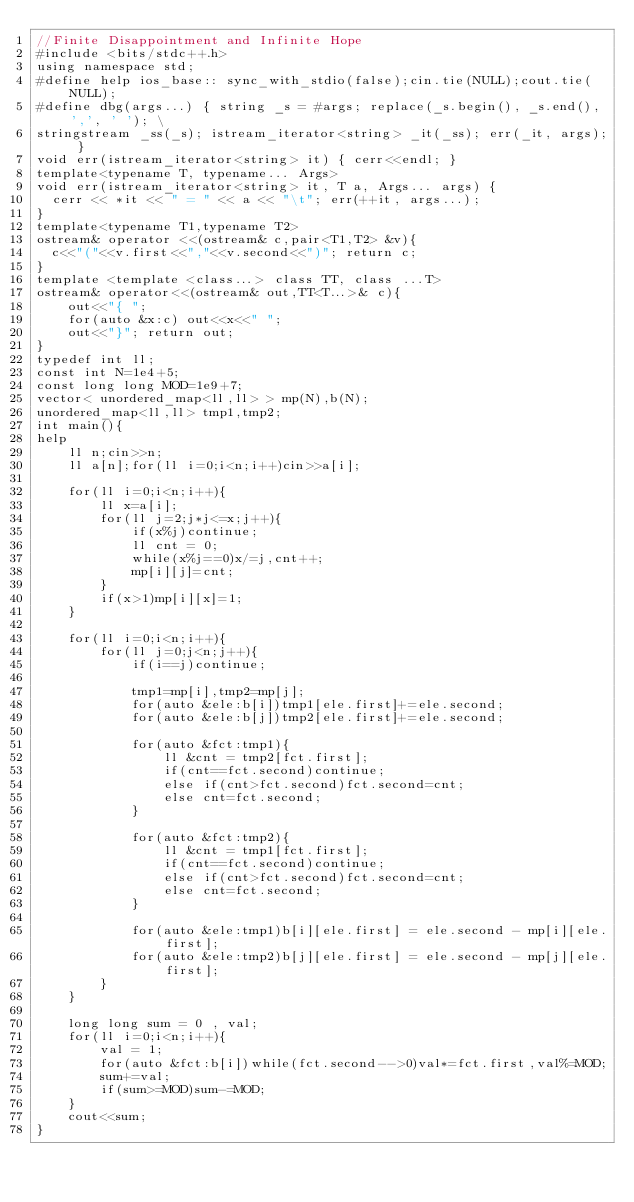Convert code to text. <code><loc_0><loc_0><loc_500><loc_500><_C++_>//Finite Disappointment and Infinite Hope
#include <bits/stdc++.h>
using namespace std;
#define help ios_base:: sync_with_stdio(false);cin.tie(NULL);cout.tie(NULL);
#define dbg(args...) { string _s = #args; replace(_s.begin(), _s.end(), ',', ' '); \
stringstream _ss(_s); istream_iterator<string> _it(_ss); err(_it, args); }
void err(istream_iterator<string> it) { cerr<<endl; }
template<typename T, typename... Args>
void err(istream_iterator<string> it, T a, Args... args) {
	cerr << *it << " = " << a << "\t"; err(++it, args...);
}
template<typename T1,typename T2>
ostream& operator <<(ostream& c,pair<T1,T2> &v){
	c<<"("<<v.first<<","<<v.second<<")"; return c;
}
template <template <class...> class TT, class ...T>
ostream& operator<<(ostream& out,TT<T...>& c){
    out<<"{ ";
    for(auto &x:c) out<<x<<" ";
    out<<"}"; return out;
}
typedef int ll;
const int N=1e4+5;
const long long MOD=1e9+7;
vector< unordered_map<ll,ll> > mp(N),b(N);
unordered_map<ll,ll> tmp1,tmp2;
int main(){
help
    ll n;cin>>n;
    ll a[n];for(ll i=0;i<n;i++)cin>>a[i];

    for(ll i=0;i<n;i++){
        ll x=a[i];
        for(ll j=2;j*j<=x;j++){
            if(x%j)continue;
            ll cnt = 0;
            while(x%j==0)x/=j,cnt++;
            mp[i][j]=cnt;
        }
        if(x>1)mp[i][x]=1;
    }

    for(ll i=0;i<n;i++){
        for(ll j=0;j<n;j++){
            if(i==j)continue;

            tmp1=mp[i],tmp2=mp[j];
            for(auto &ele:b[i])tmp1[ele.first]+=ele.second;
            for(auto &ele:b[j])tmp2[ele.first]+=ele.second;

            for(auto &fct:tmp1){
                ll &cnt = tmp2[fct.first];
                if(cnt==fct.second)continue;
                else if(cnt>fct.second)fct.second=cnt;
                else cnt=fct.second;
            }

            for(auto &fct:tmp2){
                ll &cnt = tmp1[fct.first];
                if(cnt==fct.second)continue;
                else if(cnt>fct.second)fct.second=cnt;
                else cnt=fct.second;
            }

            for(auto &ele:tmp1)b[i][ele.first] = ele.second - mp[i][ele.first];
            for(auto &ele:tmp2)b[j][ele.first] = ele.second - mp[j][ele.first];
        }
    }

    long long sum = 0 , val;
    for(ll i=0;i<n;i++){
        val = 1;
        for(auto &fct:b[i])while(fct.second-->0)val*=fct.first,val%=MOD;
        sum+=val;
        if(sum>=MOD)sum-=MOD;
    }
    cout<<sum;
}
</code> 